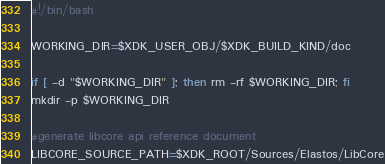Convert code to text. <code><loc_0><loc_0><loc_500><loc_500><_Bash_>#!/bin/bash

WORKING_DIR=$XDK_USER_OBJ/$XDK_BUILD_KIND/doc

if [ -d "$WORKING_DIR" ]; then rm -rf $WORKING_DIR; fi
mkdir -p $WORKING_DIR

#generate libcore api reference document
LIBCORE_SOURCE_PATH=$XDK_ROOT/Sources/Elastos/LibCore

</code> 